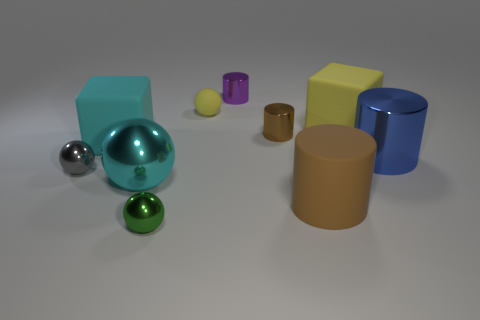Do the gray metallic sphere and the cyan matte thing have the same size?
Give a very brief answer. No. Is there a small blue cube?
Provide a short and direct response. No. Do the big yellow thing and the big matte thing to the left of the brown shiny cylinder have the same shape?
Offer a terse response. Yes. There is a block right of the rubber object in front of the gray metal ball; what is it made of?
Provide a succinct answer. Rubber. The tiny rubber ball has what color?
Provide a short and direct response. Yellow. There is a big cylinder that is in front of the gray shiny ball; does it have the same color as the tiny metal cylinder in front of the large yellow object?
Ensure brevity in your answer.  Yes. What is the size of the purple object that is the same shape as the small brown metallic thing?
Provide a succinct answer. Small. Are there any tiny cylinders of the same color as the large metal sphere?
Offer a terse response. No. There is a thing that is the same color as the big metallic sphere; what is it made of?
Provide a succinct answer. Rubber. What number of other balls have the same color as the small matte ball?
Offer a very short reply. 0. 